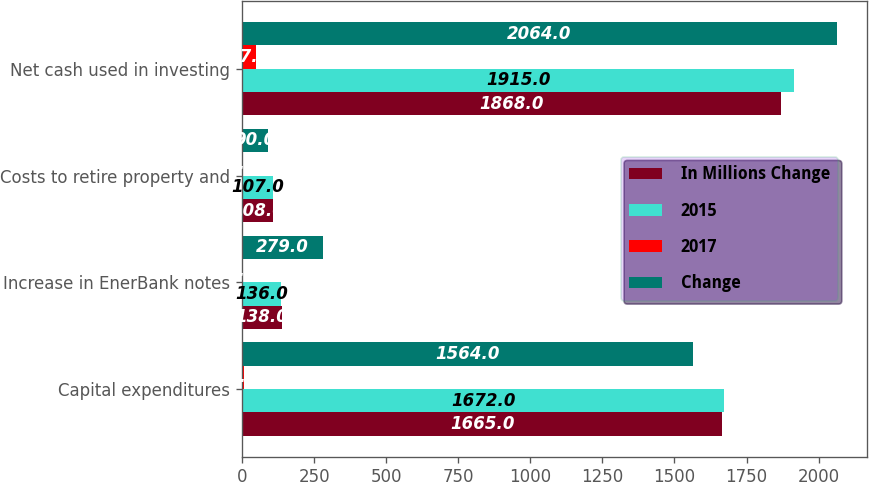Convert chart. <chart><loc_0><loc_0><loc_500><loc_500><stacked_bar_chart><ecel><fcel>Capital expenditures<fcel>Increase in EnerBank notes<fcel>Costs to retire property and<fcel>Net cash used in investing<nl><fcel>In Millions Change<fcel>1665<fcel>138<fcel>108<fcel>1868<nl><fcel>2015<fcel>1672<fcel>136<fcel>107<fcel>1915<nl><fcel>2017<fcel>7<fcel>2<fcel>1<fcel>47<nl><fcel>Change<fcel>1564<fcel>279<fcel>90<fcel>2064<nl></chart> 